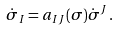<formula> <loc_0><loc_0><loc_500><loc_500>\dot { \sigma } _ { I } = a _ { I J } ( \sigma ) \dot { \sigma } ^ { J } \, .</formula> 